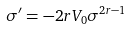Convert formula to latex. <formula><loc_0><loc_0><loc_500><loc_500>\sigma ^ { \prime } = - 2 r V _ { 0 } \sigma ^ { 2 r - 1 }</formula> 